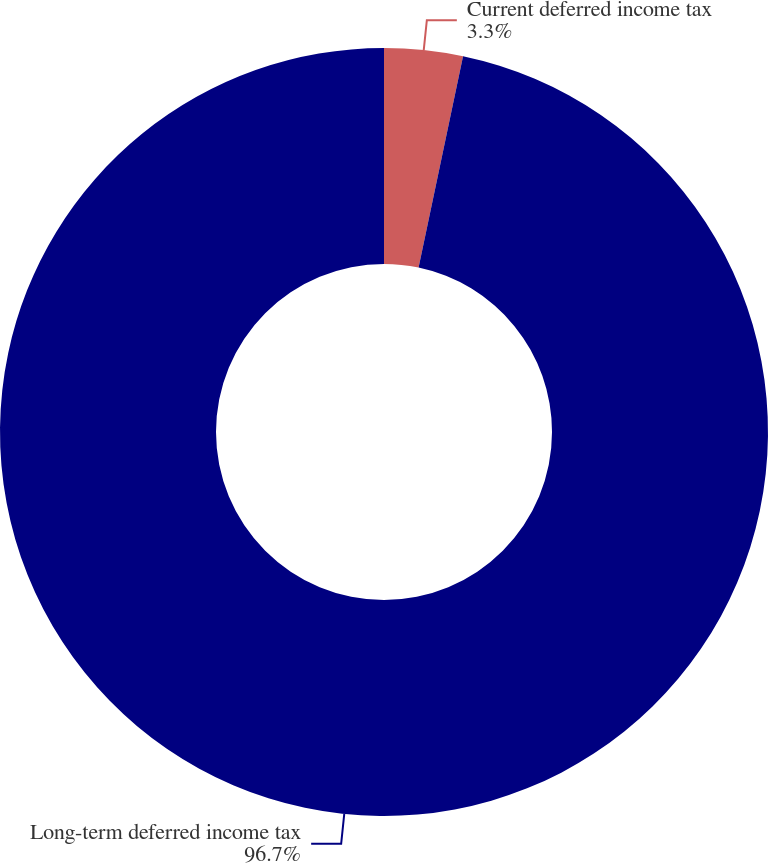Convert chart to OTSL. <chart><loc_0><loc_0><loc_500><loc_500><pie_chart><fcel>Current deferred income tax<fcel>Long-term deferred income tax<nl><fcel>3.3%<fcel>96.7%<nl></chart> 